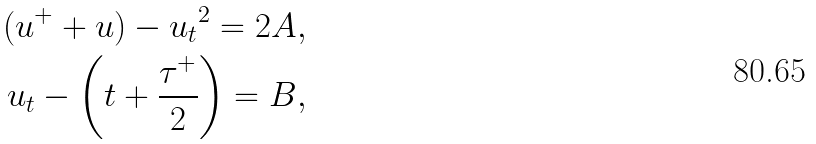<formula> <loc_0><loc_0><loc_500><loc_500>( u ^ { + } + u ) - { u _ { t } } ^ { 2 } = 2 A , \\ { u _ { t } } - \left ( t + \frac { \tau ^ { + } } { 2 } \right ) = B ,</formula> 